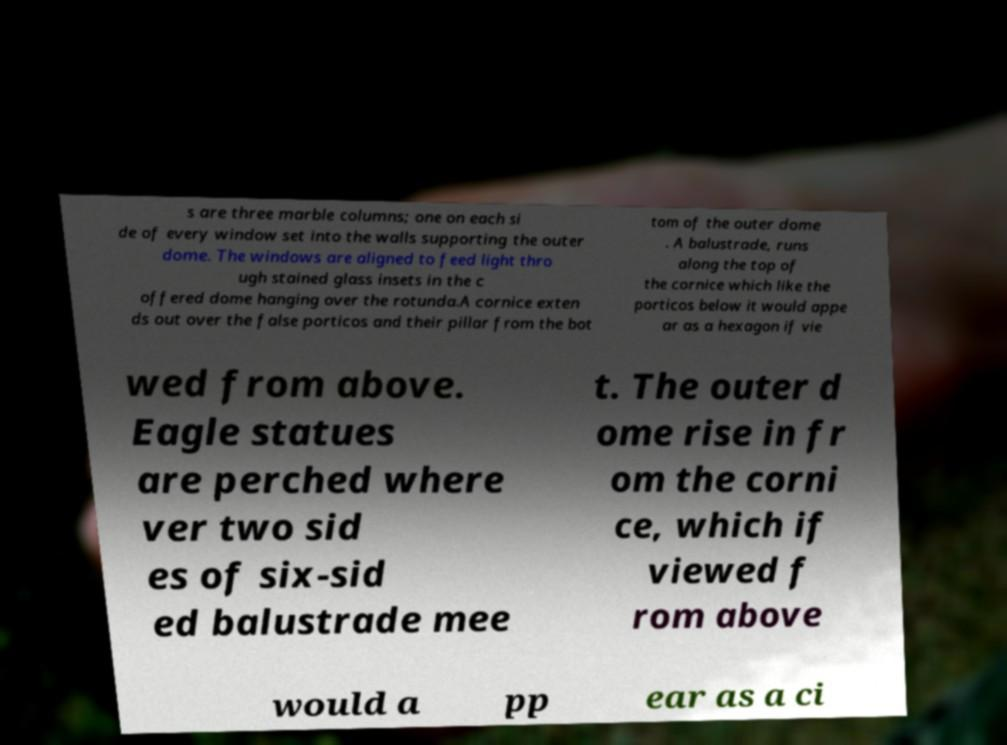For documentation purposes, I need the text within this image transcribed. Could you provide that? s are three marble columns; one on each si de of every window set into the walls supporting the outer dome. The windows are aligned to feed light thro ugh stained glass insets in the c offered dome hanging over the rotunda.A cornice exten ds out over the false porticos and their pillar from the bot tom of the outer dome . A balustrade, runs along the top of the cornice which like the porticos below it would appe ar as a hexagon if vie wed from above. Eagle statues are perched where ver two sid es of six-sid ed balustrade mee t. The outer d ome rise in fr om the corni ce, which if viewed f rom above would a pp ear as a ci 